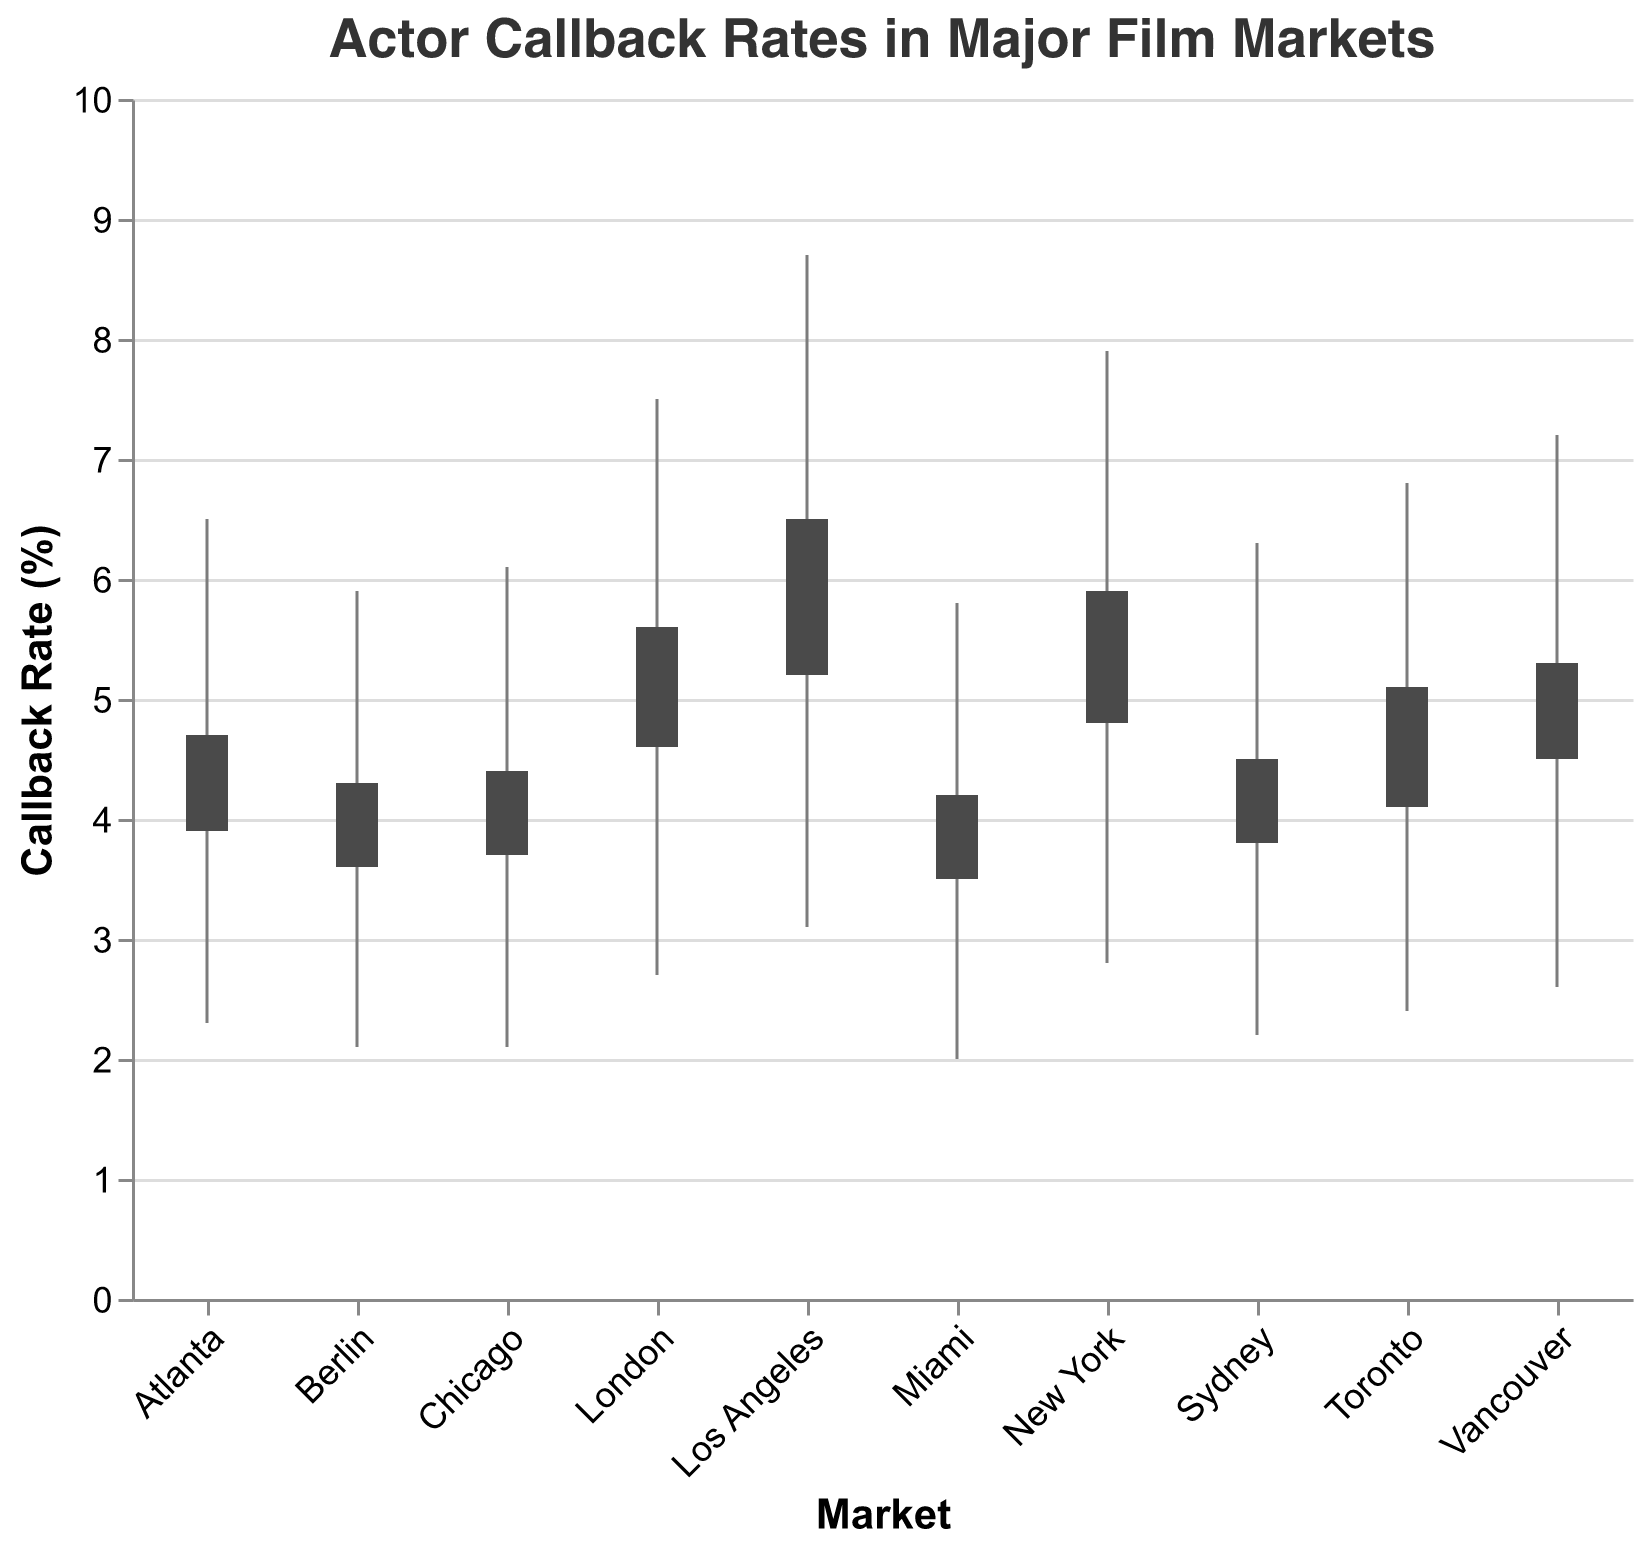What is the title of the chart? The title is typically located at the top of the chart and provides a brief summary of what the chart is about. Here, it states "Actor Callback Rates in Major Film Markets."
Answer: Actor Callback Rates in Major Film Markets Which market has the highest callback rate during its peak? The 'High' value on the y-axis denotes the peak callback rate across different markets. Los Angeles shows the highest point at 8.7%.
Answer: Los Angeles What are the callback rates at the beginning and end of the pilot season in New York? Referring to New York's 'Open' and 'Close' values, the rates are 4.8% and 5.9%, respectively.
Answer: 4.8% and 5.9% Which market has the smallest range between its highest and lowest callback rates? The range is the difference between the 'High' and 'Low' values for each market. Miami has the smallest range, calculated as 5.8 - 2.0 = 3.8%.
Answer: Miami How do the opening callback rates of Los Angeles compare to London? By comparing the 'Open' values for both markets, Los Angeles starts at 5.2%, while London opens at 4.6%.
Answer: Los Angeles (5.2%) is higher than London (4.6%) What is the average high callback rate across all markets? To find the average high callback rate, sum up all 'High' values and divide by the number of markets: (8.7 + 7.9 + 6.5 + 7.2 + 6.1 + 6.8 + 5.8 + 7.5 + 6.3 + 5.9) / 10 = 6.87%.
Answer: 6.87% Which market has the lowest closing callback rate? The 'Close' value denotes the callback rate at the end. Miami has the lowest close at 4.2%.
Answer: Miami How much did the callback rate in Berlin increase from the lowest point to the highest point? The increase is calculated by subtracting the 'Low' value from the 'High' value for Berlin: 5.9 - 2.1 = 3.8%.
Answer: 3.8% Which market had the largest fluctuation in callback rates during the pilot season? The fluctuation is the difference between 'High' and 'Low' values. Los Angeles has the largest fluctuation, calculated as 8.7 - 3.1 = 5.6%.
Answer: Los Angeles What is the median closing callback rate across all markets? Arrange all 'Close' values in ascending order and find the middle value. For 10 values, the median is the average of the 5th and 6th values: (4.7 + 5.1) / 2 = 4.9%.
Answer: 4.9% 